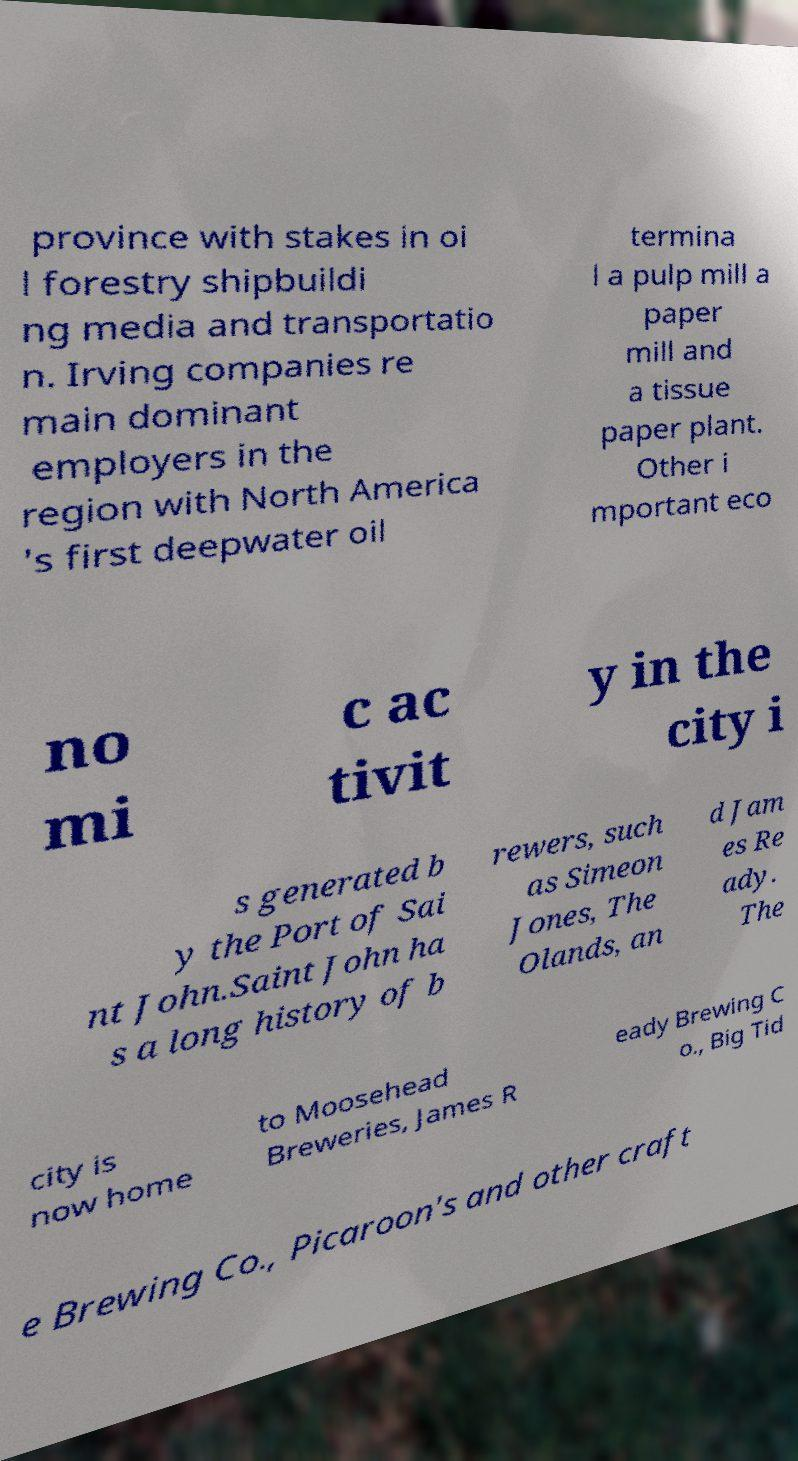I need the written content from this picture converted into text. Can you do that? province with stakes in oi l forestry shipbuildi ng media and transportatio n. Irving companies re main dominant employers in the region with North America 's first deepwater oil termina l a pulp mill a paper mill and a tissue paper plant. Other i mportant eco no mi c ac tivit y in the city i s generated b y the Port of Sai nt John.Saint John ha s a long history of b rewers, such as Simeon Jones, The Olands, an d Jam es Re ady. The city is now home to Moosehead Breweries, James R eady Brewing C o., Big Tid e Brewing Co., Picaroon's and other craft 